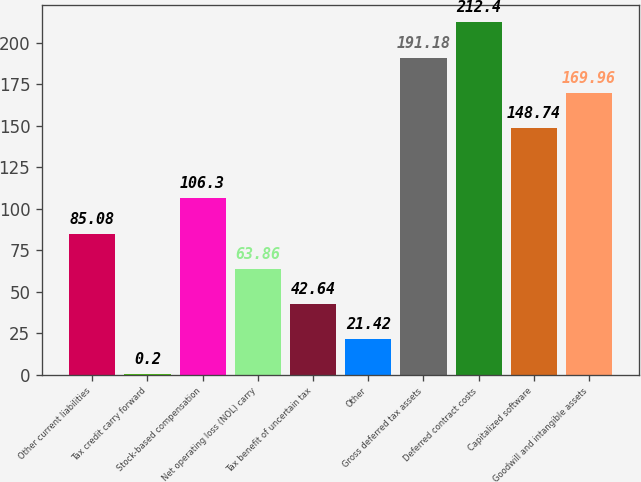<chart> <loc_0><loc_0><loc_500><loc_500><bar_chart><fcel>Other current liabilities<fcel>Tax credit carry forward<fcel>Stock-based compensation<fcel>Net operating loss (NOL) carry<fcel>Tax benefit of uncertain tax<fcel>Other<fcel>Gross deferred tax assets<fcel>Deferred contract costs<fcel>Capitalized software<fcel>Goodwill and intangible assets<nl><fcel>85.08<fcel>0.2<fcel>106.3<fcel>63.86<fcel>42.64<fcel>21.42<fcel>191.18<fcel>212.4<fcel>148.74<fcel>169.96<nl></chart> 